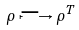<formula> <loc_0><loc_0><loc_500><loc_500>\rho \longmapsto \rho ^ { T }</formula> 